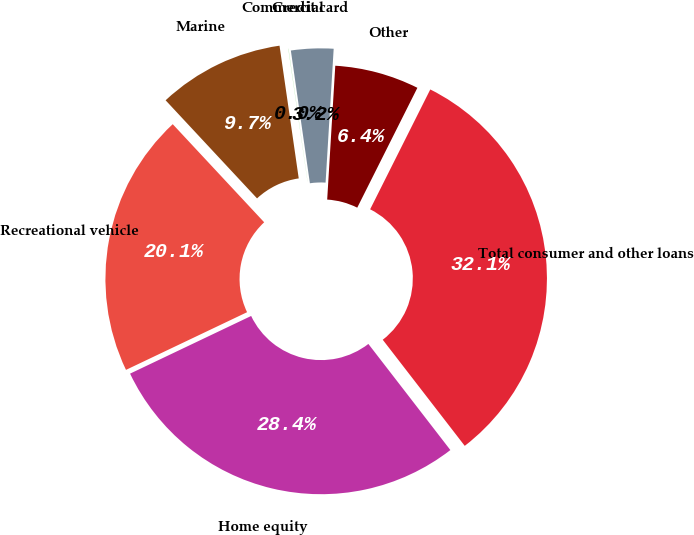Convert chart. <chart><loc_0><loc_0><loc_500><loc_500><pie_chart><fcel>Home equity<fcel>Recreational vehicle<fcel>Marine<fcel>Commercial<fcel>Credit card<fcel>Other<fcel>Total consumer and other loans<nl><fcel>28.39%<fcel>20.13%<fcel>9.65%<fcel>0.02%<fcel>3.23%<fcel>6.44%<fcel>32.12%<nl></chart> 